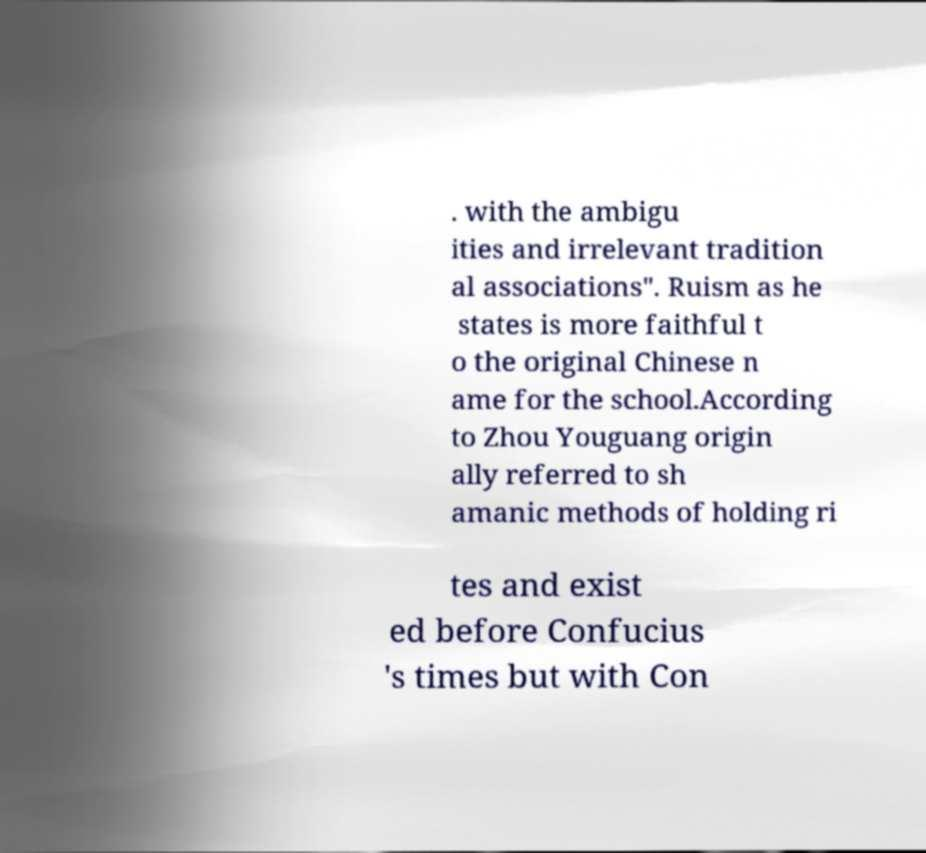For documentation purposes, I need the text within this image transcribed. Could you provide that? . with the ambigu ities and irrelevant tradition al associations". Ruism as he states is more faithful t o the original Chinese n ame for the school.According to Zhou Youguang origin ally referred to sh amanic methods of holding ri tes and exist ed before Confucius 's times but with Con 